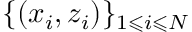Convert formula to latex. <formula><loc_0><loc_0><loc_500><loc_500>\{ ( x _ { i } , z _ { i } ) \} _ { 1 \leqslant i \leqslant N }</formula> 